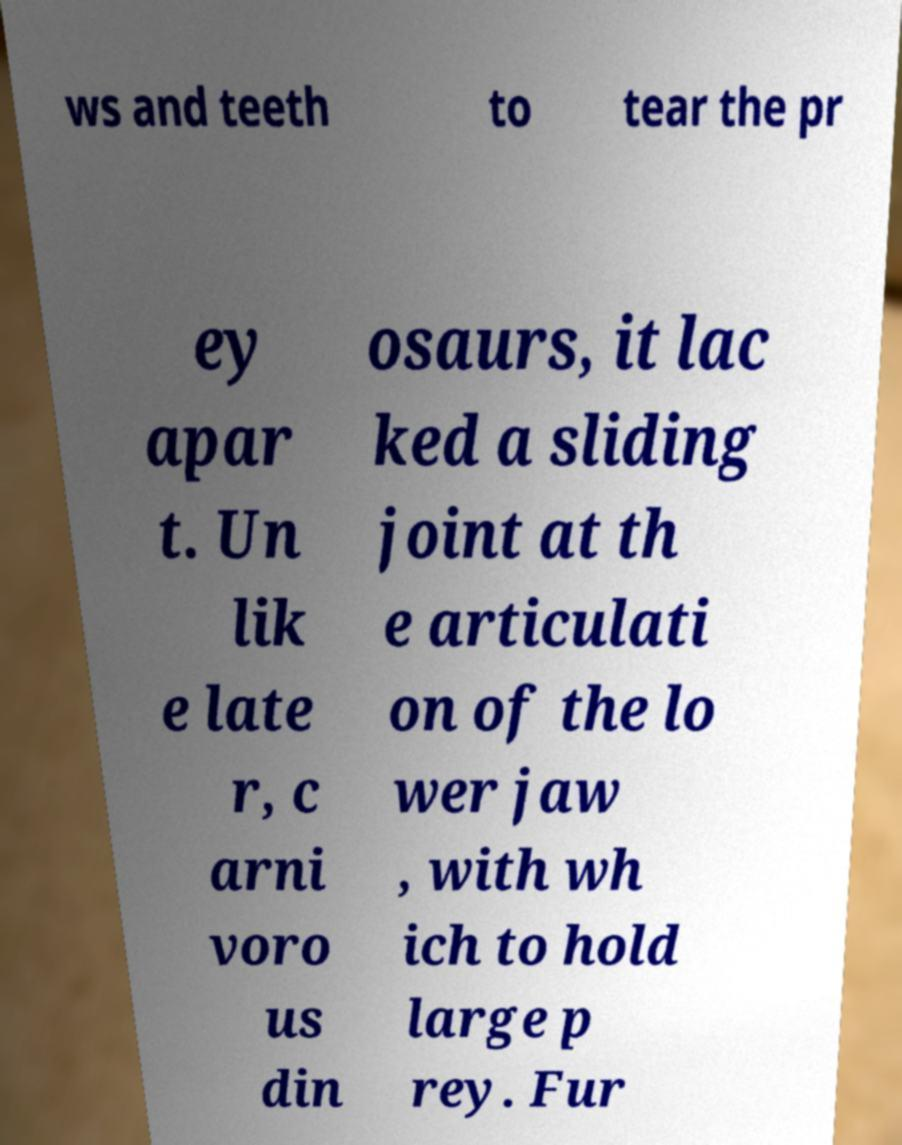I need the written content from this picture converted into text. Can you do that? ws and teeth to tear the pr ey apar t. Un lik e late r, c arni voro us din osaurs, it lac ked a sliding joint at th e articulati on of the lo wer jaw , with wh ich to hold large p rey. Fur 